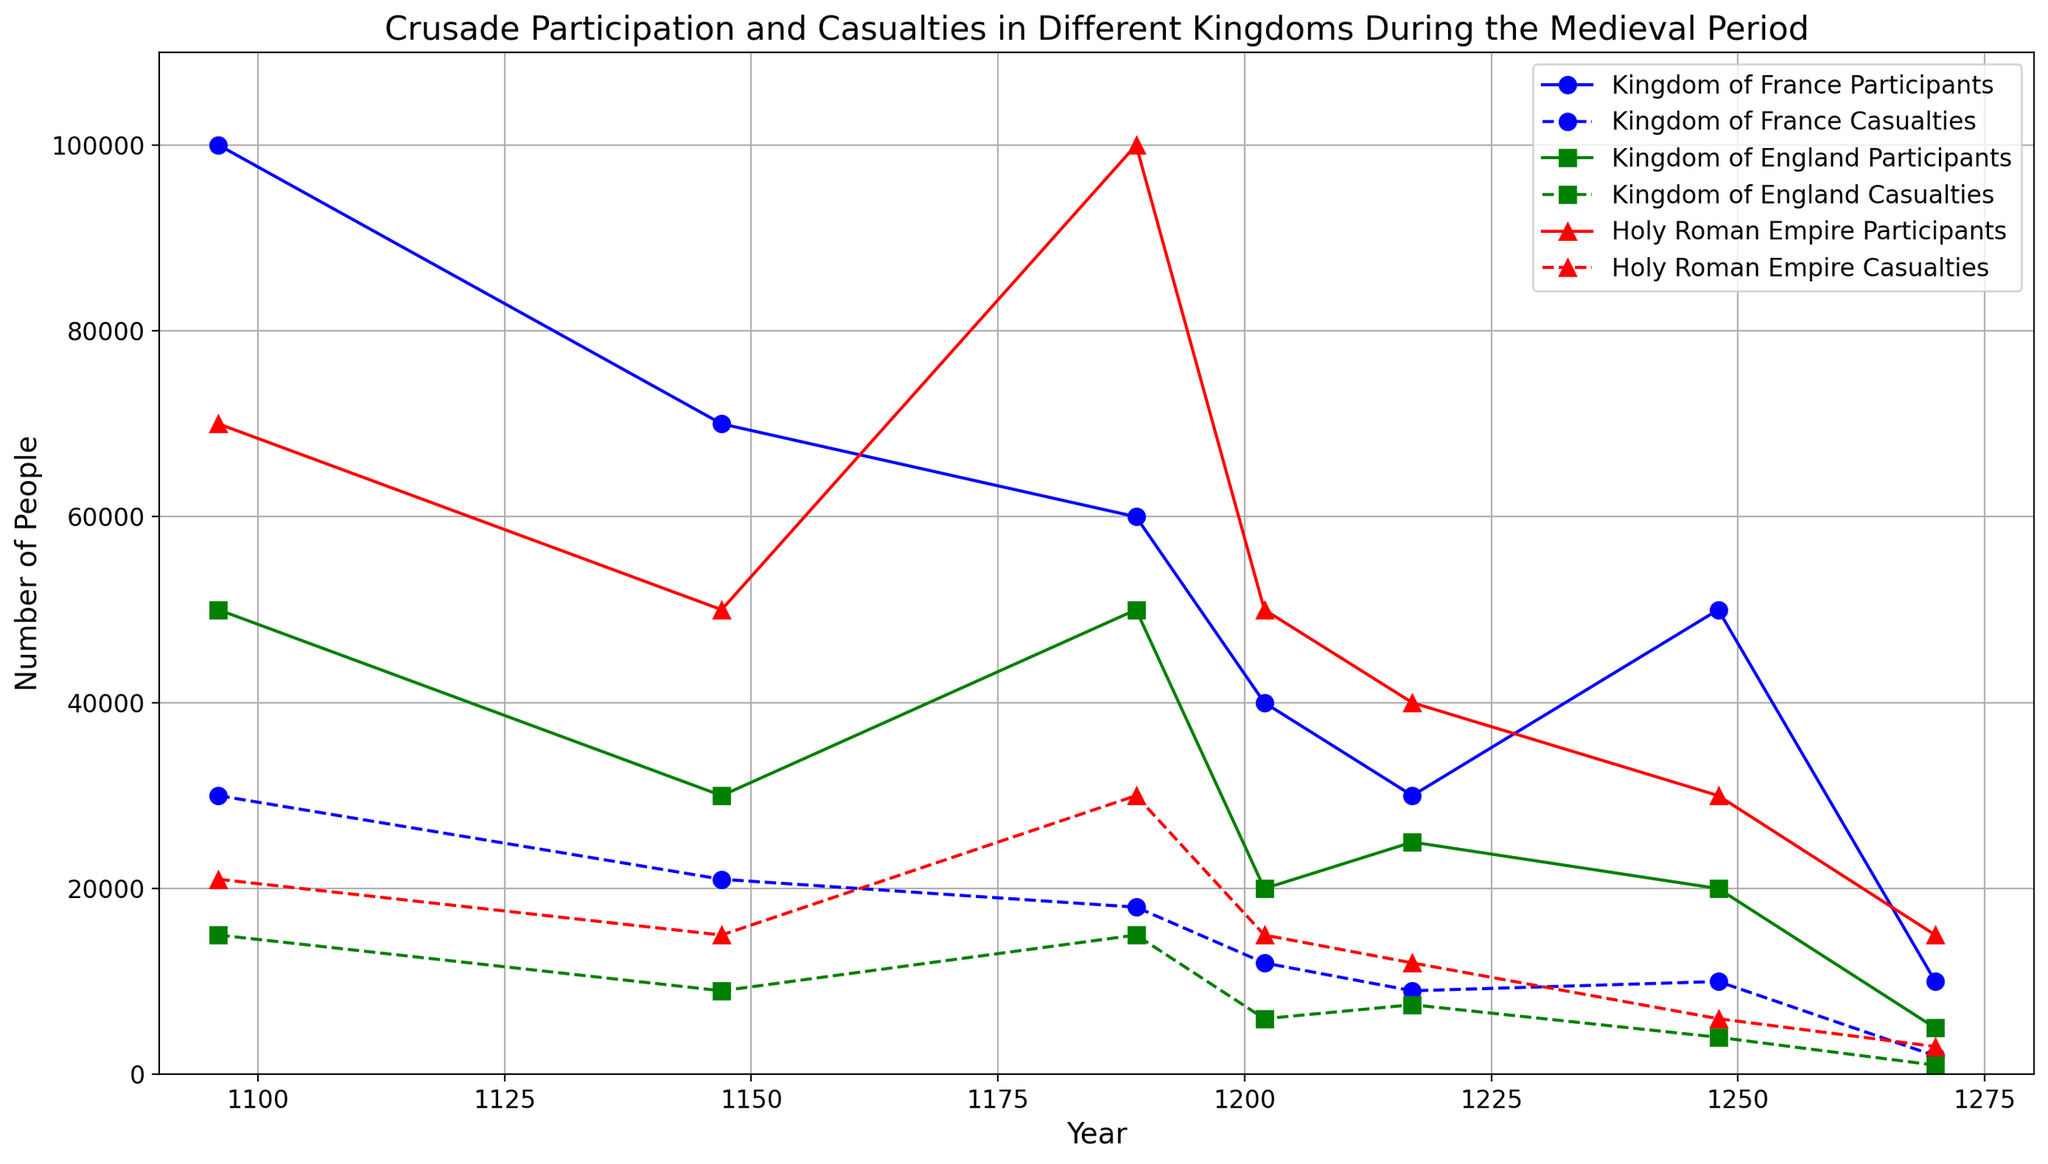What was the total number of participants from the Kingdom of France across all years? Summing the participants of the Kingdom of France: 100000 (1096) + 70000 (1147) + 60000 (1189) + 40000 (1202) + 30000 (1217) + 50000 (1248) + 10000 (1270) = 360000
Answer: 360000 How do the casualties of the Kingdom of England in 1202 compare to those in 1248? The casualties of the Kingdom of England's are 6000 in 1202 and 4000 in 1248. By comparing, 6000 is greater than 4000
Answer: 6000 is greater than 4000 Which kingdom had the highest number of casualties in the year 1189? In the year 1189, the casualties were: Kingdom of France: 18000, Kingdom of England: 15000, Holy Roman Empire: 30000. The Holy Roman Empire had the highest number.
Answer: Holy Roman Empire What is the average number of participants for the Holy Roman Empire in the years 1096, 1147, and 1189? Summing the participants for these years: 70000 (1096) + 50000 (1147) + 100000 (1189) equals 220000. There are 3 years, so 220000 / 3 equals approximately 73333.33
Answer: 73333.33 In which year did the Kingdom of France have the lowest number of participants? The participants are plotted, and the lowest value for the Kingdom of France is in 1270 with 10000 participants.
Answer: 1270 Compare the number of participants and casualties for the Holy Roman Empire in 1248. In 1248, the Holy Roman Empire had 30000 participants and 6000 casualties.
Answer: 30000 participants and 6000 casualties How many more participants did the Kingdom of France have in 1096 compared to 1248? Kingdom of France had 100000 participants in 1096 and 50000 in 1248, so the difference is 100000 - 50000 = 50000
Answer: 50000 What can be inferred about the trend of participants from the Kingdom of England over the years shown in the chart? The participants start at 50000 in 1096, then decrease to 30000 in 1147, 50000 in 1189, 20000 in 1202, and finally go down to 5000 by 1270, showing a general decreasing trend.
Answer: Decreasing trend Among the three kingdoms, which had the most consistent trend in the number of casualties over the years? Observing the fluctuation trends, the Kingdom of England shows the most consistent trend with decreasing casualties over time.
Answer: Kingdom of England 